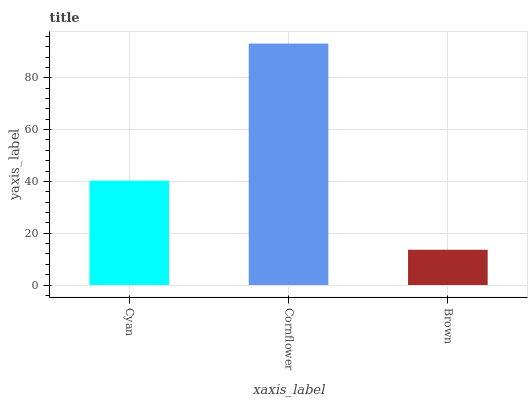Is Brown the minimum?
Answer yes or no. Yes. Is Cornflower the maximum?
Answer yes or no. Yes. Is Cornflower the minimum?
Answer yes or no. No. Is Brown the maximum?
Answer yes or no. No. Is Cornflower greater than Brown?
Answer yes or no. Yes. Is Brown less than Cornflower?
Answer yes or no. Yes. Is Brown greater than Cornflower?
Answer yes or no. No. Is Cornflower less than Brown?
Answer yes or no. No. Is Cyan the high median?
Answer yes or no. Yes. Is Cyan the low median?
Answer yes or no. Yes. Is Brown the high median?
Answer yes or no. No. Is Cornflower the low median?
Answer yes or no. No. 